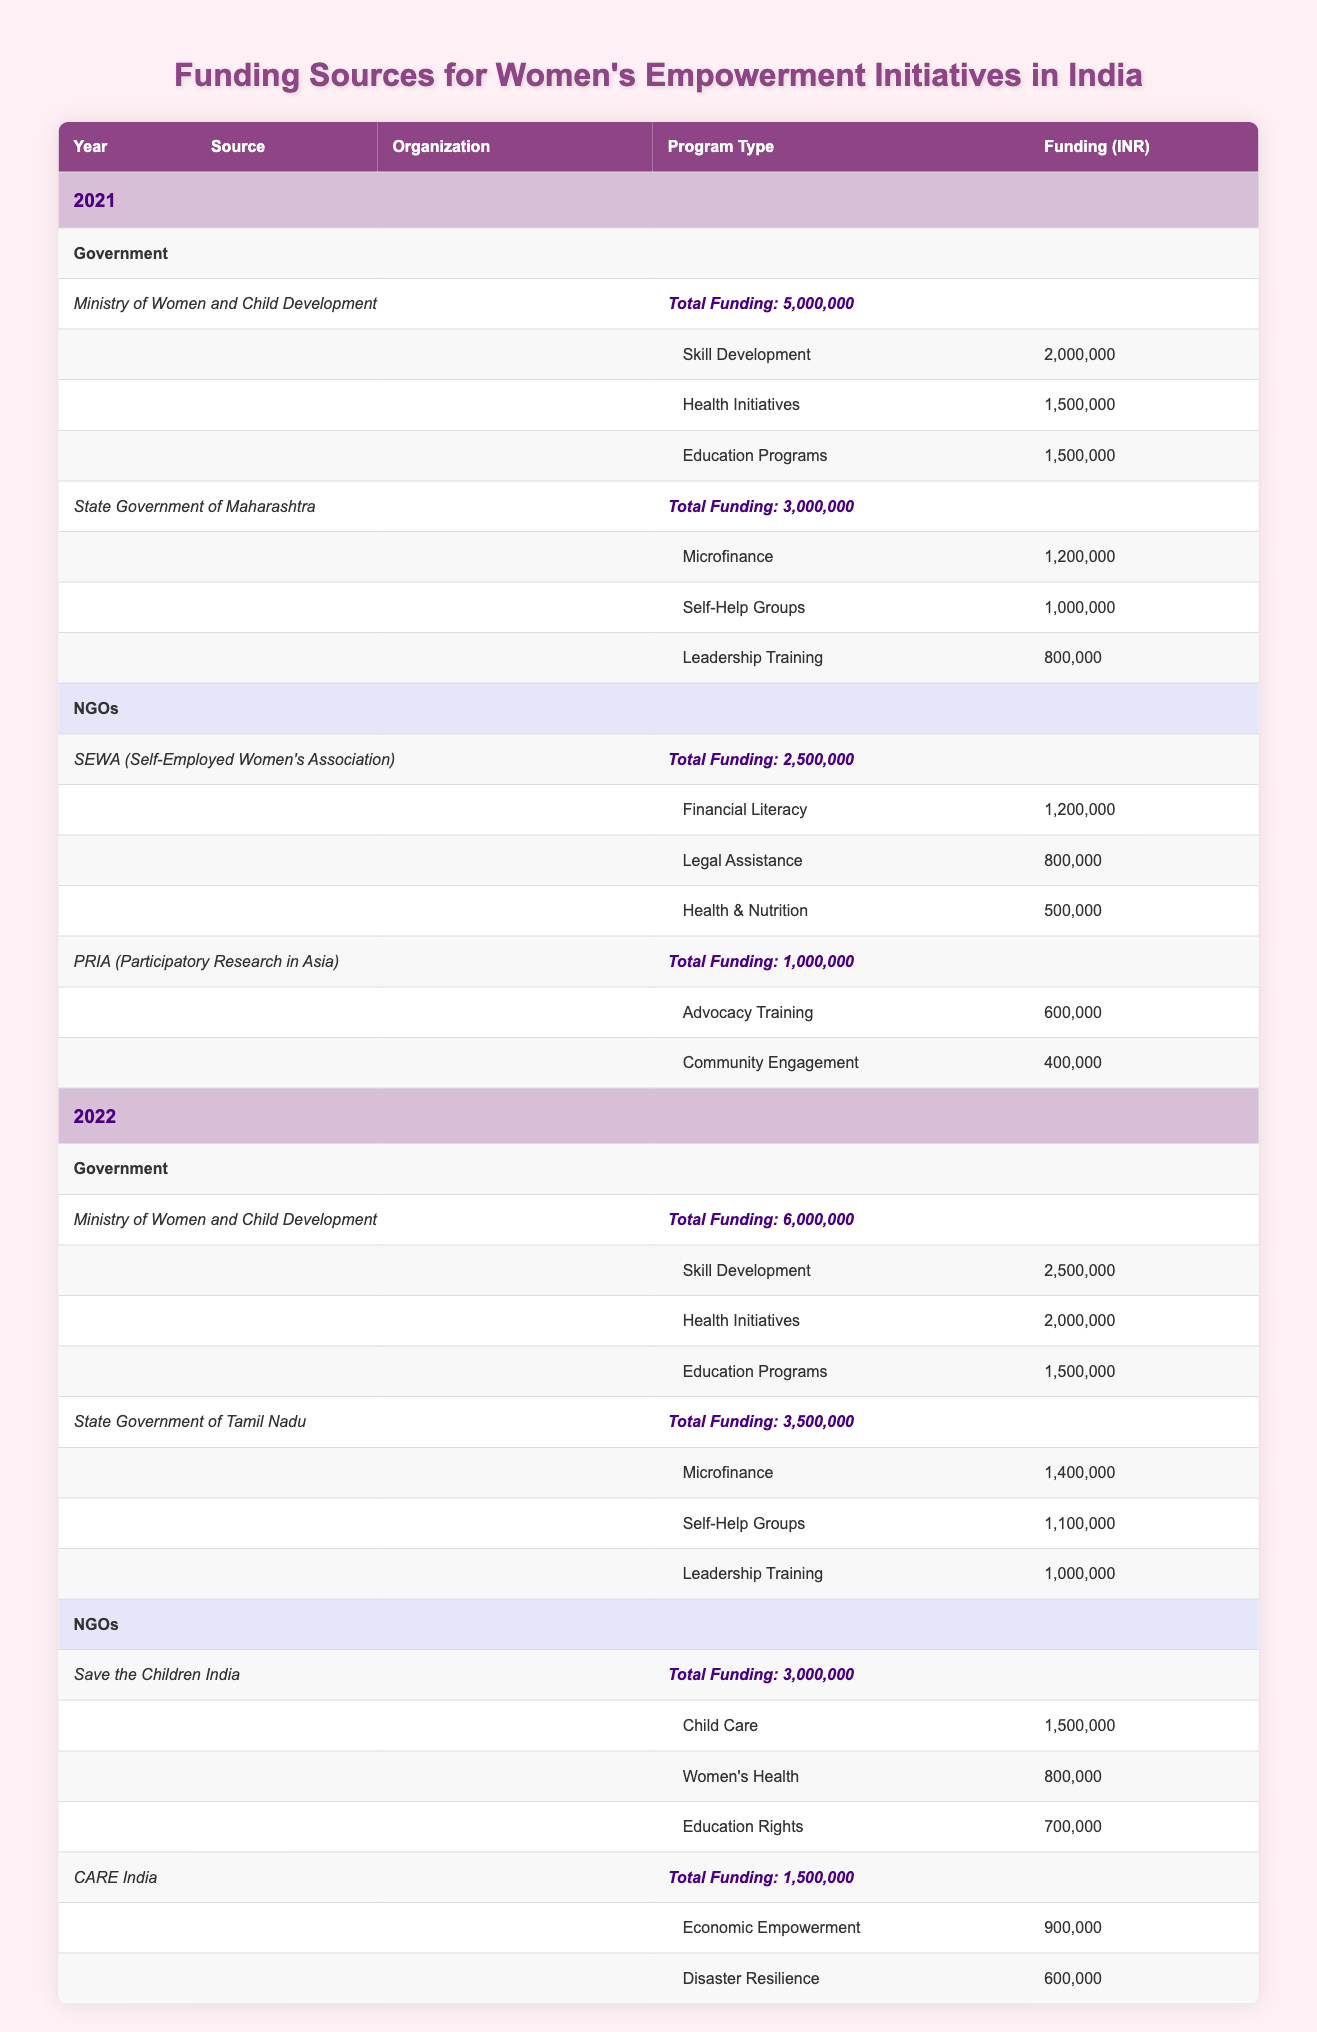What is the total funding received by the Ministry of Women and Child Development in 2021? In 2021, the funding received by the Ministry of Women and Child Development is listed as 5,000,000.
Answer: 5,000,000 How much funding did SEWA receive for Financial Literacy programs in 2021? From the table, SEWA received 1,200,000 for Financial Literacy programs in 2021.
Answer: 1,200,000 Which program type received the highest funding from the State Government of Maharashtra in 2021? Looking at the program types, Microfinance received 1,200,000, Self-Help Groups received 1,000,000, and Leadership Training received 800,000. Microfinance has the highest amount.
Answer: Microfinance Is the total funding from NGOs higher in 2022 compared to 2021? Total funding from NGOs in 2022 is 4,500,000 (3,000,000 + 1,500,000) while in 2021 it is 3,500,000 (2,500,000 + 1,000,000). Thus, it is higher in 2022.
Answer: Yes What is the difference in total funding for skill development programs between 2021 and 2022? In 2021, funding for skill development is 2,000,000, and in 2022 it is 2,500,000. The difference is 2,500,000 - 2,000,000 = 500,000.
Answer: 500,000 How much funding did the State Government of Tamil Nadu allocate for Leadership Training in 2022? The State Government of Tamil Nadu allocated 1,000,000 for Leadership Training in 2022, according to the table.
Answer: 1,000,000 Which source provided the funding for Education Rights in 2022? The source for the funding of Education Rights in 2022 is Save the Children India, with 700,000 allocated for this program type.
Answer: Save the Children India Is the total funding for Health Initiatives the same in both 2021 and 2022? In 2021, the total funding for Health Initiatives is 1,500,000, while in 2022 it is 2,000,000. Therefore, they are not the same, as 2,000,000 is greater than 1,500,000.
Answer: No What is the total funding provided by the State Government of Maharashtra for all program types in 2021? The total funding from the State Government of Maharashtra across all program types is 1,200,000 (Microfinance) + 1,000,000 (Self-Help Groups) + 800,000 (Leadership Training) = 3,000,000.
Answer: 3,000,000 